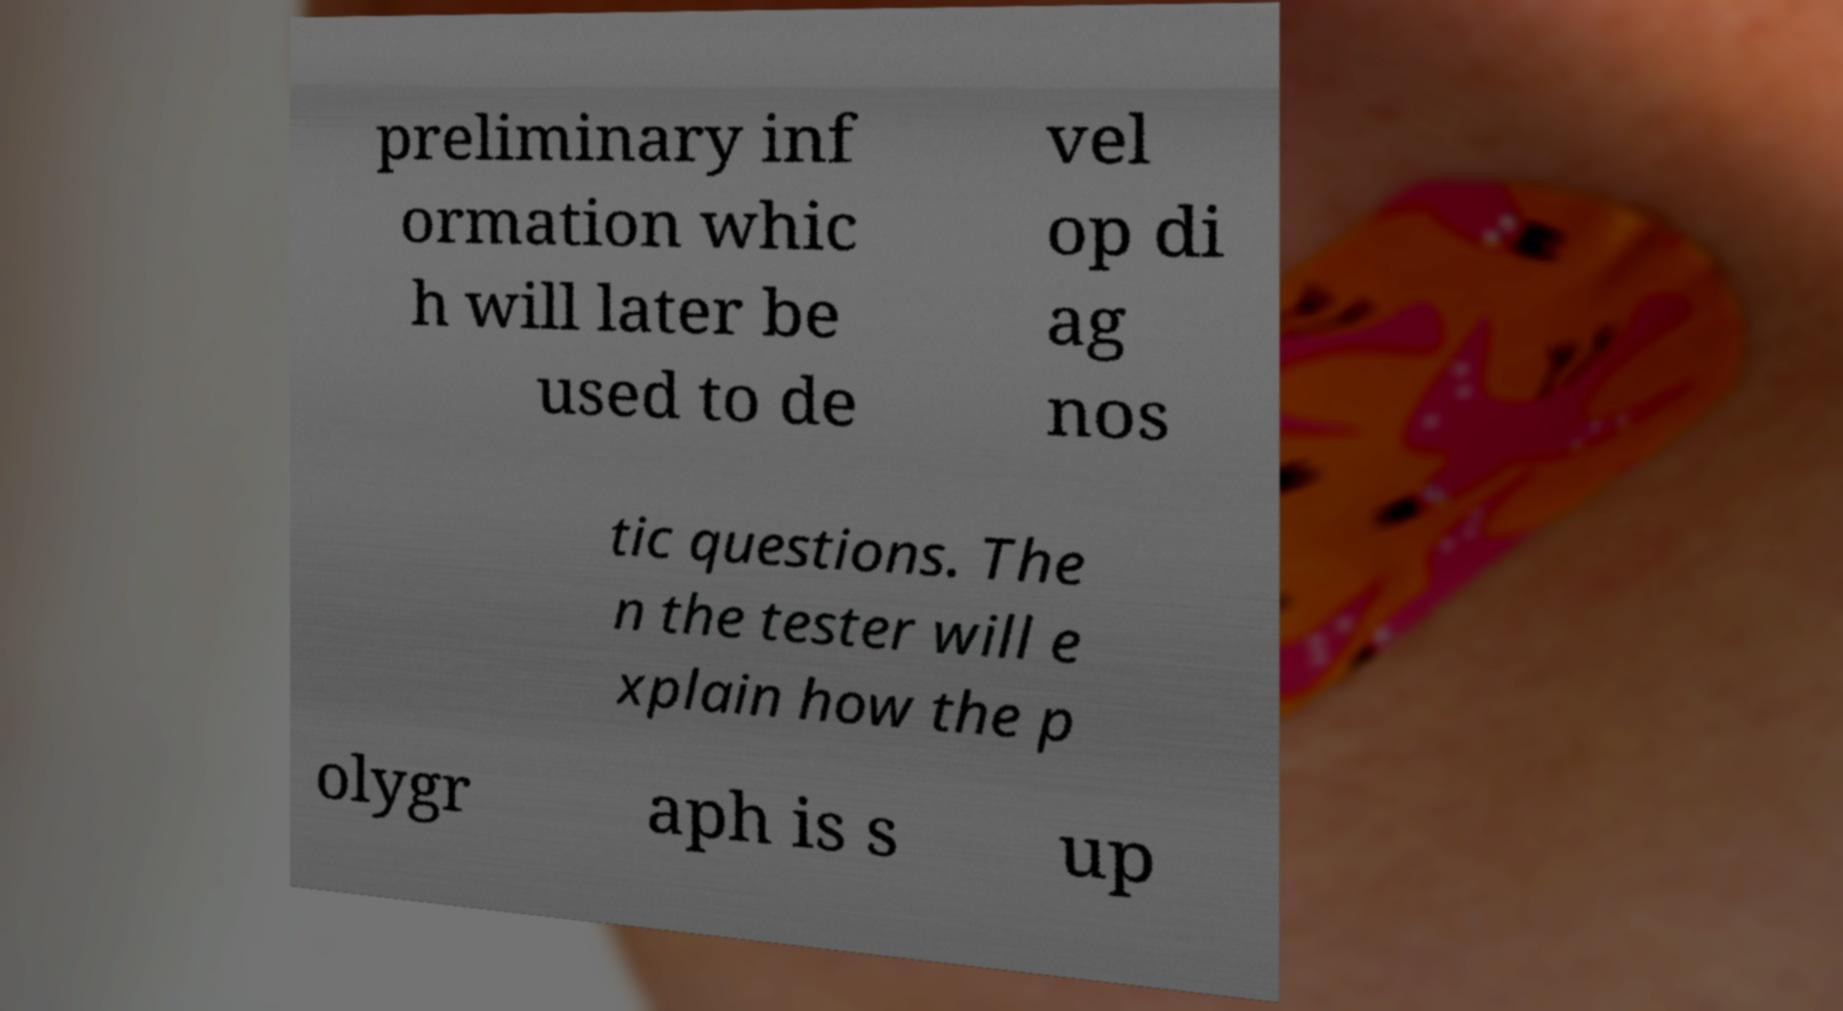Please identify and transcribe the text found in this image. preliminary inf ormation whic h will later be used to de vel op di ag nos tic questions. The n the tester will e xplain how the p olygr aph is s up 